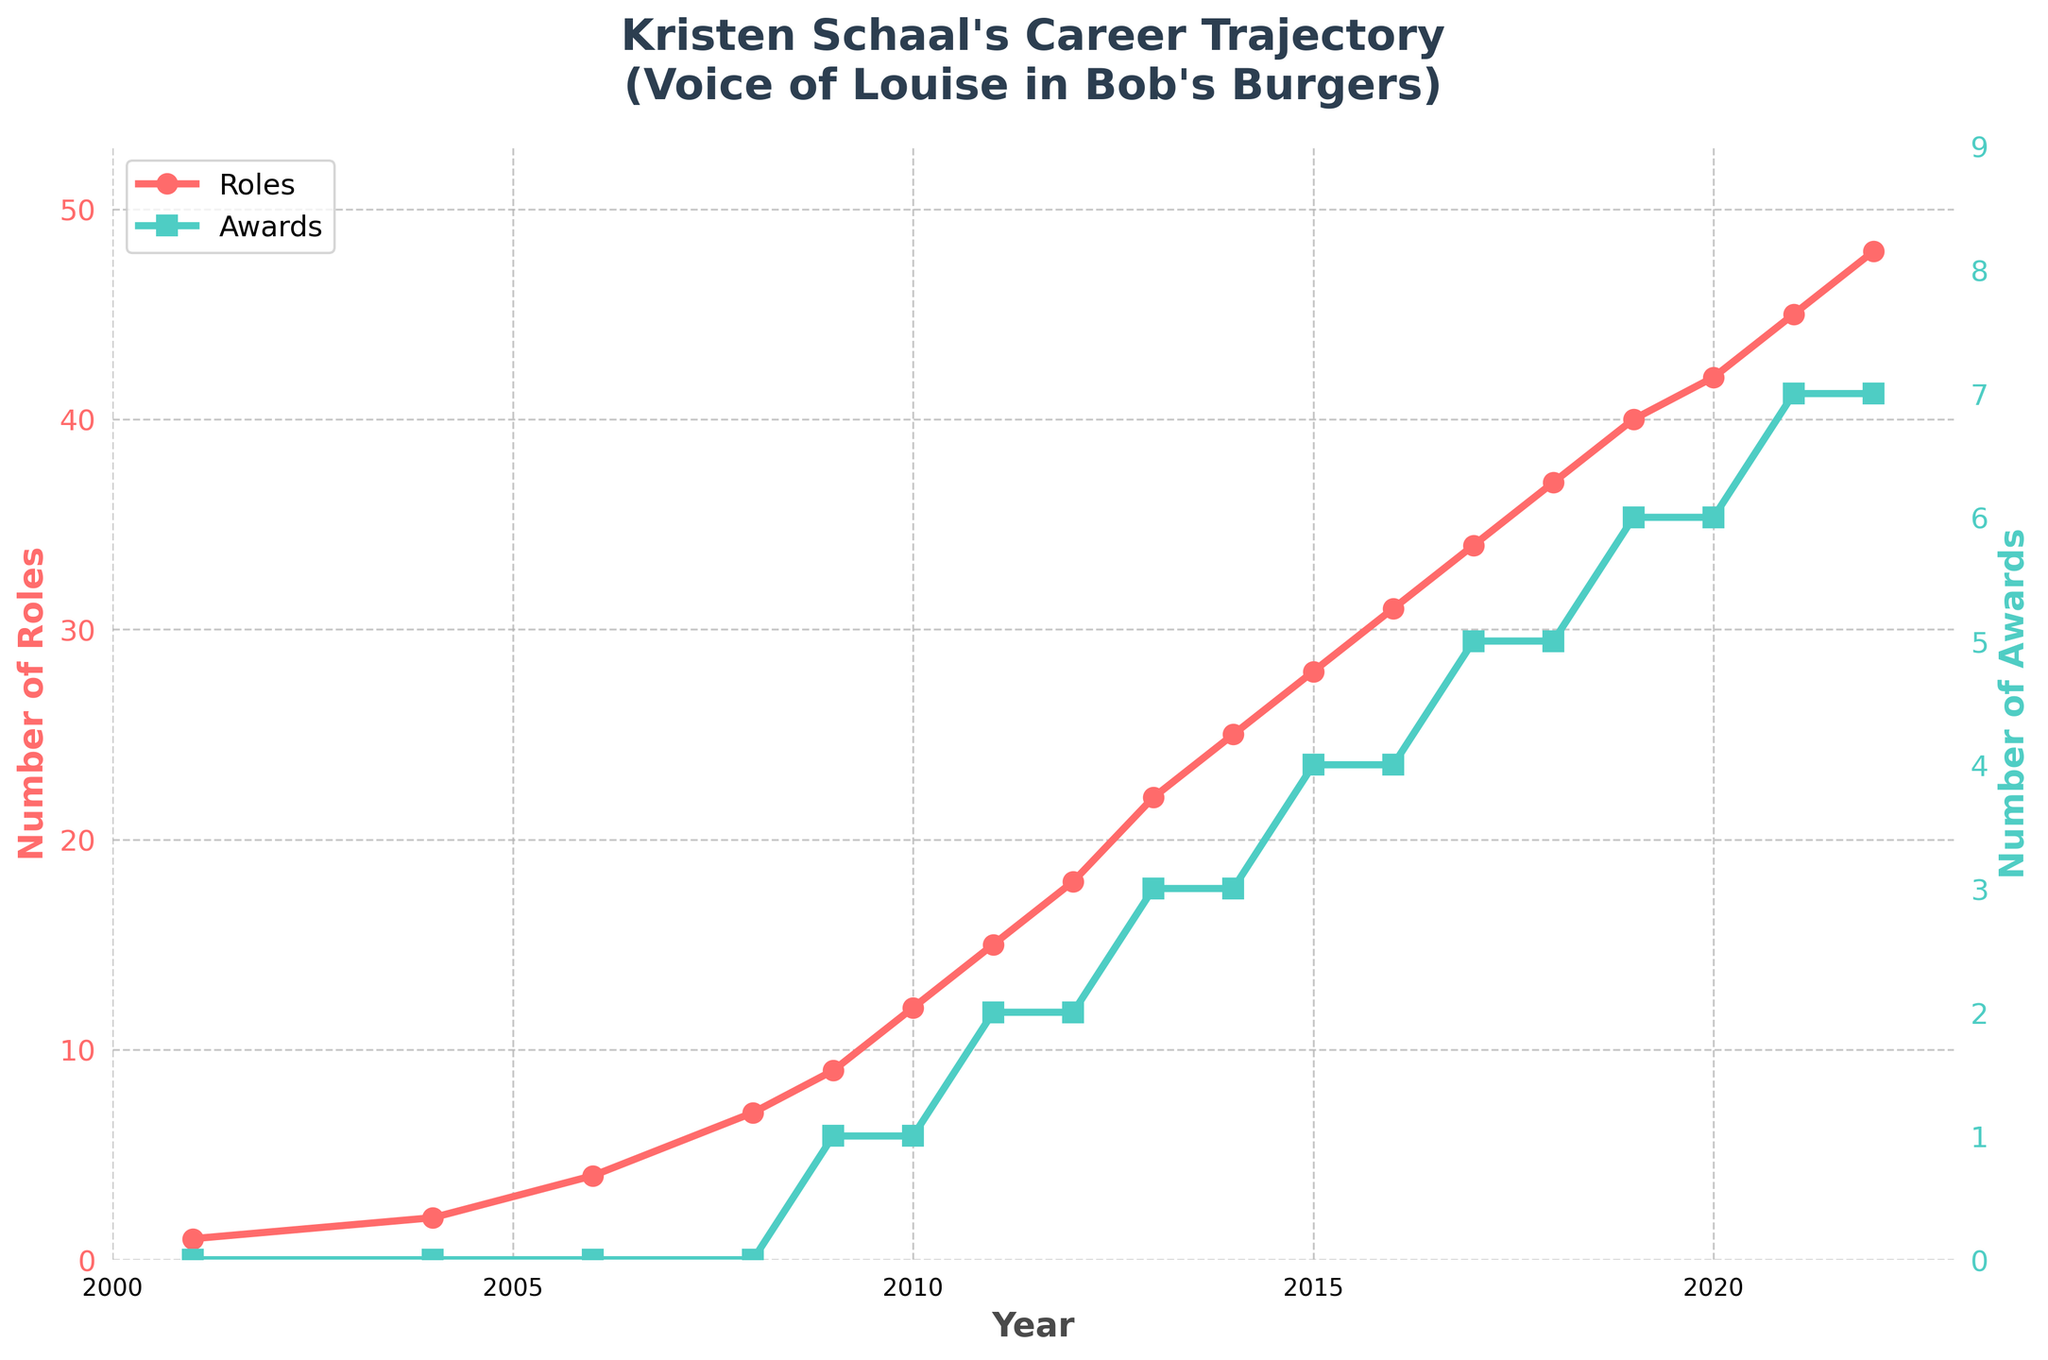When did Kristen Schaal start receiving awards for her roles? According to the chart, Kristen Schaal started receiving awards in 2009.
Answer: 2009 How many more roles did Kristen Schaal have in 2015 compared to 2011? Kristen had 28 roles in 2015 and 15 roles in 2011. The difference is 28 - 15.
Answer: 13 Which year shows the highest growth in the number of Kristen Schaal's roles? The steepest slope in the number of roles occurs between 2010 and 2011, where the roles went from 12 to 15.
Answer: 2011 How many awards had Kristen Schaal won by 2020? By referring to the awards axis on the right, the chart shows that by 2020, she had won 6 awards.
Answer: 6 Describe the trend in Kristen Schaal's number of roles after Bob's Burgers premiered in 2011. After 2011, the number of roles increased each year consistently, showing a positive upward trend from 15 roles in 2011 to 48 roles in 2022.
Answer: Increasing trend Compare the cumulative number of Kristen Schaal's roles before and after 2011. Before 2011, she had 1+2+4+7+9+12+15 = 50 roles. After 2011, she had 18+22+25+28+31+34+37+40+42+45+48 = 370 roles.
Answer: 370 vs. 50 How does the number of roles in 2017 compare to the number of awards in the same year? In 2017, Kristen had 34 roles and 5 awards, showing that she had 29 more roles than awards in that year.
Answer: 29 more roles In what year did Kristen Schaal's number of awards double from the previous year's count? The number of awards doubled from 2 to 4 between 2014 and 2015.
Answer: 2015 Calculate the average number of roles Kristen Schaal held per year from 2010 to 2015. The roles from 2010 to 2015 are 12, 15, 18, 22, 25, and 28. Sum these values (12+15+18+22+25+28=120) and divide by the number of years (6).
Answer: 20 What visual annotation is highlighted on the chart, and what significance does it denote? The annotation indicates "Bob's Burgers Premiers" at the year 2011, which is significant as it marks the start of a notable upward trend in Kristen's career.
Answer: Bob's Burgers Premiers - 2011 